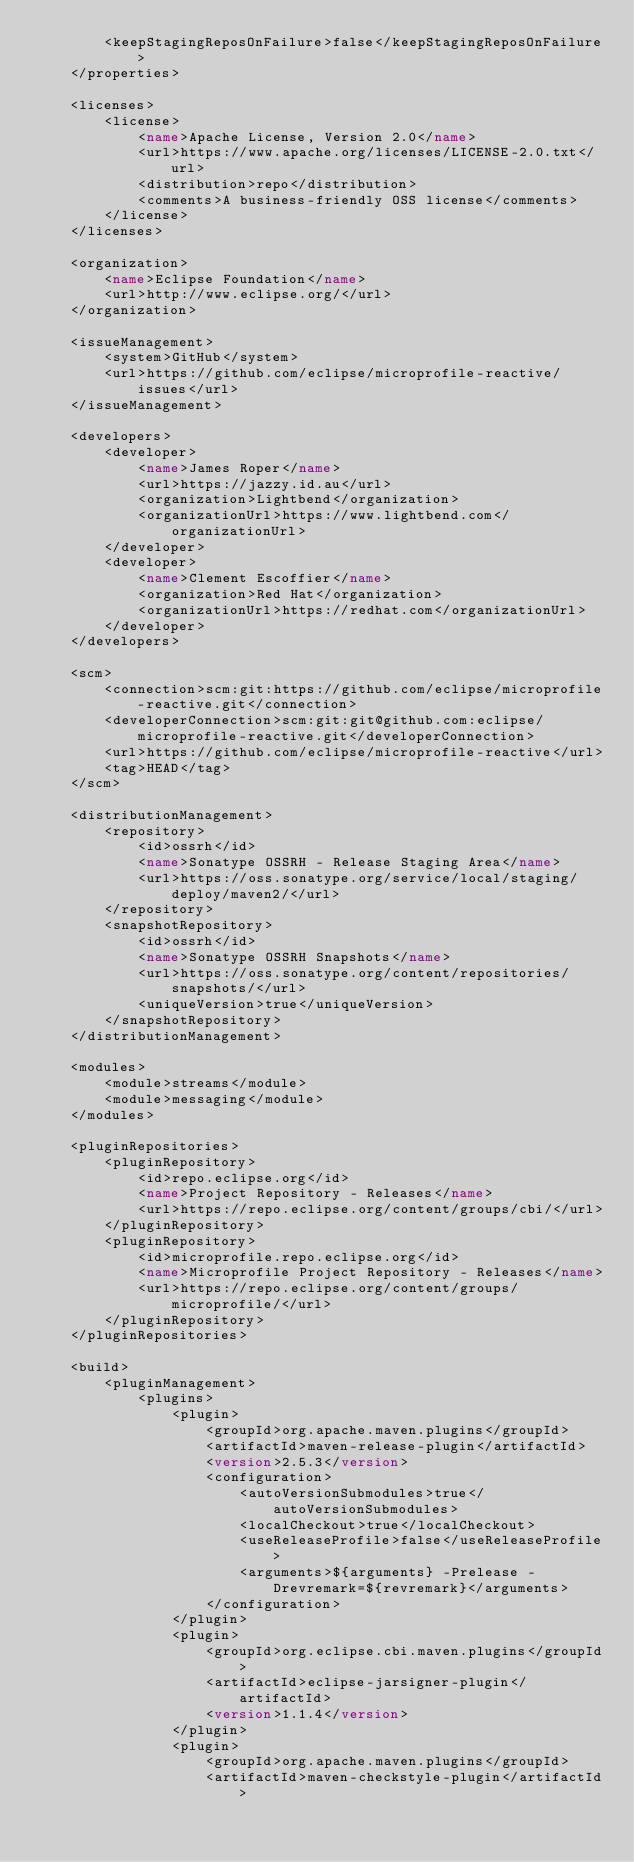Convert code to text. <code><loc_0><loc_0><loc_500><loc_500><_XML_>        <keepStagingReposOnFailure>false</keepStagingReposOnFailure>
    </properties>

    <licenses>
        <license>
            <name>Apache License, Version 2.0</name>
            <url>https://www.apache.org/licenses/LICENSE-2.0.txt</url>
            <distribution>repo</distribution>
            <comments>A business-friendly OSS license</comments>
        </license>
    </licenses>

    <organization>
        <name>Eclipse Foundation</name>
        <url>http://www.eclipse.org/</url>
    </organization>

    <issueManagement>
        <system>GitHub</system>
        <url>https://github.com/eclipse/microprofile-reactive/issues</url>
    </issueManagement>

    <developers>
        <developer>
            <name>James Roper</name>
            <url>https://jazzy.id.au</url>
            <organization>Lightbend</organization>
            <organizationUrl>https://www.lightbend.com</organizationUrl>
        </developer>
        <developer>
            <name>Clement Escoffier</name>
            <organization>Red Hat</organization>
            <organizationUrl>https://redhat.com</organizationUrl>
        </developer>
    </developers>

    <scm>
        <connection>scm:git:https://github.com/eclipse/microprofile-reactive.git</connection>
        <developerConnection>scm:git:git@github.com:eclipse/microprofile-reactive.git</developerConnection>
        <url>https://github.com/eclipse/microprofile-reactive</url>
        <tag>HEAD</tag>
    </scm>

    <distributionManagement>
        <repository>
            <id>ossrh</id>
            <name>Sonatype OSSRH - Release Staging Area</name>
            <url>https://oss.sonatype.org/service/local/staging/deploy/maven2/</url>
        </repository>
        <snapshotRepository>
            <id>ossrh</id>
            <name>Sonatype OSSRH Snapshots</name>
            <url>https://oss.sonatype.org/content/repositories/snapshots/</url>
            <uniqueVersion>true</uniqueVersion>
        </snapshotRepository>
    </distributionManagement>

    <modules>
        <module>streams</module>
        <module>messaging</module>
    </modules>

    <pluginRepositories>
        <pluginRepository>
            <id>repo.eclipse.org</id>
            <name>Project Repository - Releases</name>
            <url>https://repo.eclipse.org/content/groups/cbi/</url>
        </pluginRepository>
        <pluginRepository>
            <id>microprofile.repo.eclipse.org</id>
            <name>Microprofile Project Repository - Releases</name>
            <url>https://repo.eclipse.org/content/groups/microprofile/</url>
        </pluginRepository>
    </pluginRepositories>

    <build>
        <pluginManagement>
            <plugins>
                <plugin>
                    <groupId>org.apache.maven.plugins</groupId>
                    <artifactId>maven-release-plugin</artifactId>
                    <version>2.5.3</version>
                    <configuration>
                        <autoVersionSubmodules>true</autoVersionSubmodules>
                        <localCheckout>true</localCheckout>
                        <useReleaseProfile>false</useReleaseProfile>
                        <arguments>${arguments} -Prelease -Drevremark=${revremark}</arguments>
                    </configuration>
                </plugin>
                <plugin>
                    <groupId>org.eclipse.cbi.maven.plugins</groupId>
                    <artifactId>eclipse-jarsigner-plugin</artifactId>
                    <version>1.1.4</version>
                </plugin>
                <plugin>
                    <groupId>org.apache.maven.plugins</groupId>
                    <artifactId>maven-checkstyle-plugin</artifactId></code> 